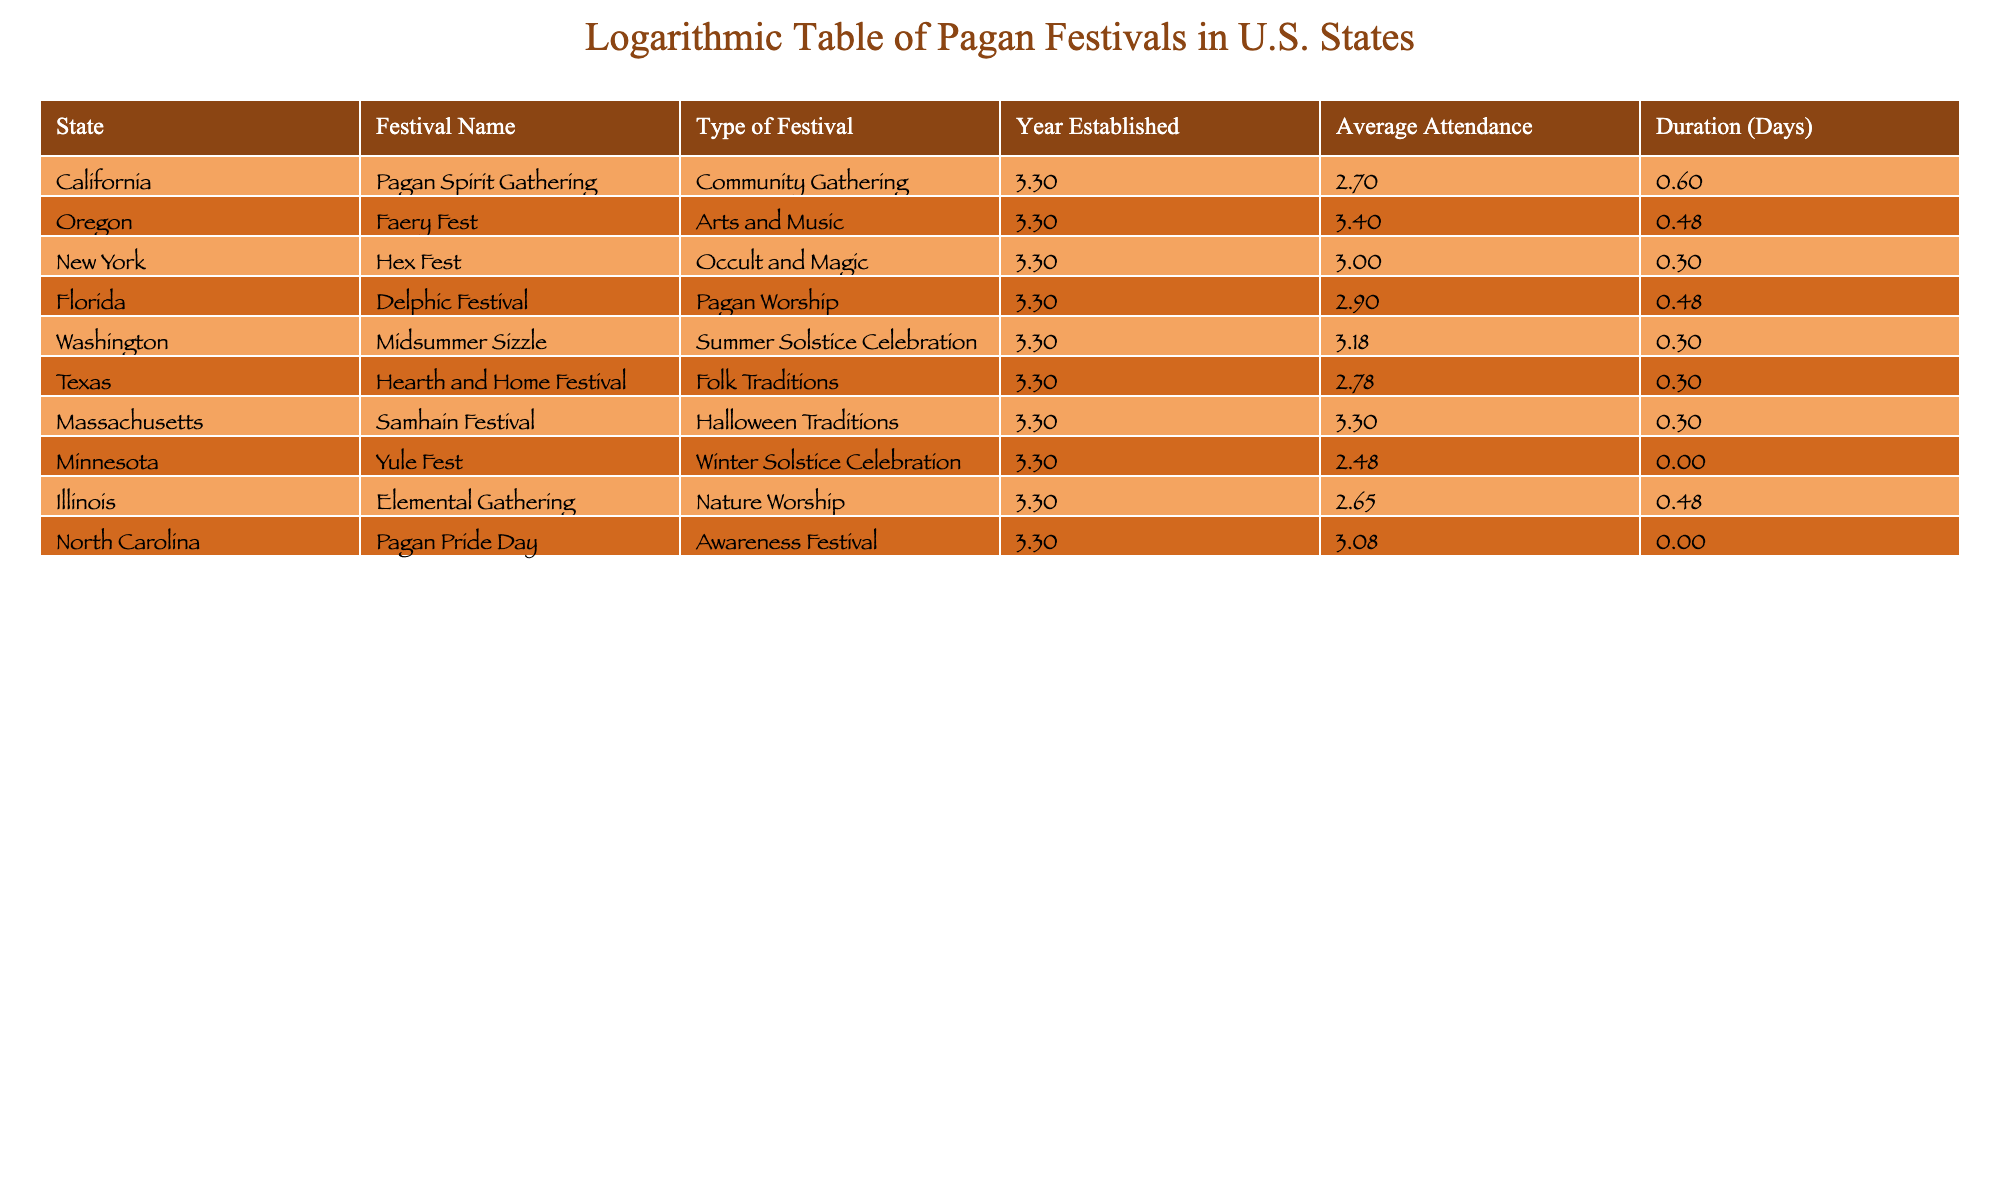What is the festival with the highest average attendance? To find the festival with the highest average attendance, I compare the 'Average Attendance' values from all the festivals listed. The highest value is 2500, which corresponds to the 'Faery Fest' in Oregon.
Answer: Faery Fest Which festival has been established the earliest? Looking at the 'Year Established' column, the earliest year is 1990, which is for the 'Pagan Spirit Gathering' in California.
Answer: Pagan Spirit Gathering What is the average duration of the festivals listed in days? To calculate the average duration, I sum up the 'Duration (Days)' values: (4 + 3 + 2 + 3 + 2 + 2 + 2 + 1 + 1) = 20. There are 9 festivals, so the average duration is 20/9 ≈ 2.22 days.
Answer: 2.22 Is there a festival specifically focused on Pagan worship? By checking the 'Type of Festival' column, I find that the 'Delphic Festival' in Florida is categorized under Pagan Worship. Therefore, yes, there is a festival specifically focused on that theme.
Answer: Yes How many festivals have an average attendance greater than 1000? I filter the 'Average Attendance' column for values greater than 1000. The festivals that meet this criterion are 'Faery Fest', 'Samhain Festival', and 'Midsummer Sizzle', which totals to 3 festivals.
Answer: 3 What is the difference in average attendance between the highest and lowest attendance festivals? The highest average attendance is 2500 for 'Faery Fest' and the lowest is 300 for 'Yule Fest'. The difference is 2500 - 300 = 2200.
Answer: 2200 Is there a festival that lasts only one day? From the 'Duration (Days)' column, I identify festivals with a duration of 1 day. The 'Yule Fest' and 'Pagan Pride Day' both have a duration of 1 day, confirming that there are two such festivals.
Answer: Yes Which state hosts the 'Samhain Festival'? By referencing the 'Festival Name' column, I see that the 'Samhain Festival' is held in Massachusetts.
Answer: Massachusetts Which type of festival has the most attendees in this table? I analyze the 'Type of Festival' column in conjunction with 'Average Attendance'. 'Arts and Music' (Faery Fest) has 2500 attendees, while the rest have smaller attendance figures. Thus, 'Arts and Music' is the type with the highest attendees.
Answer: Arts and Music 